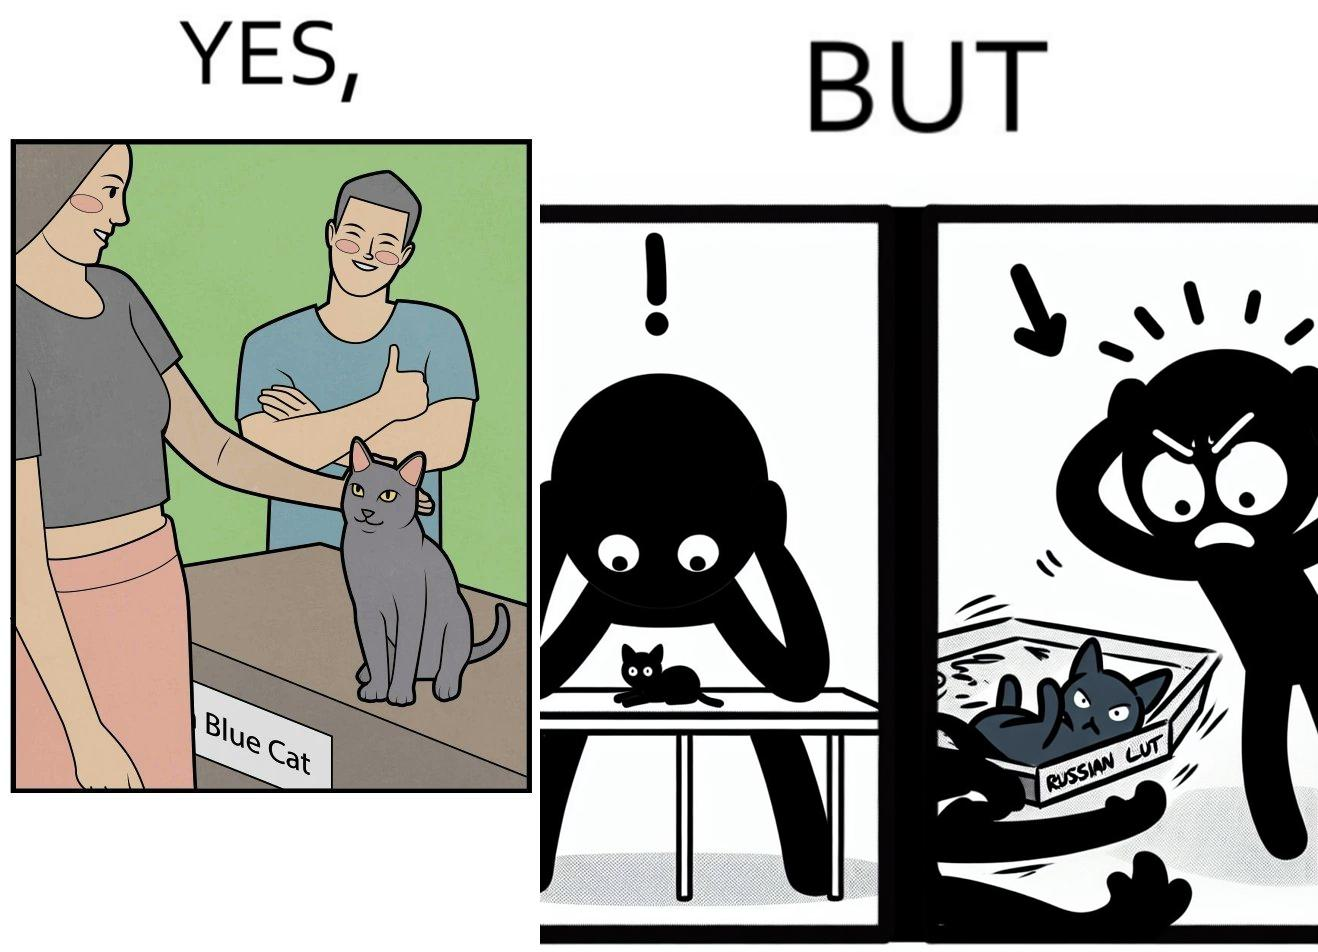Describe what you see in this image. The image is confusing, as initially, when the label reads "Blue Cat", the people are happy and are petting tha cat, but as soon as one of them realizes that the entire text reads "Russian Blue Cat", they seem to worried, and one of them throws away the cat. For some reason, the word "Russian" is a trigger word for them. 